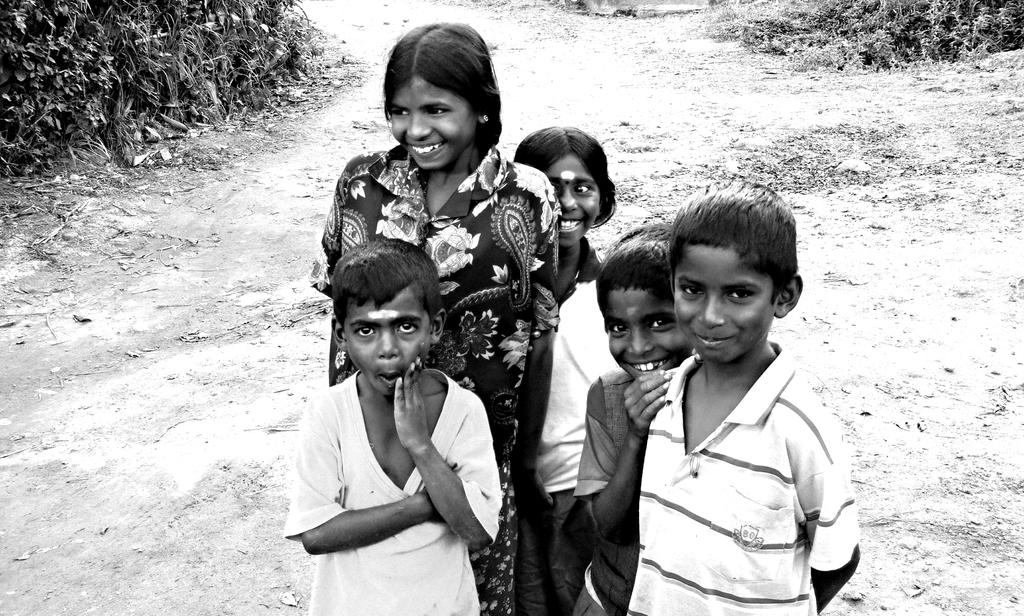What is the color scheme of the image? The image is black and white. How many people are in the image? There are a few people in the image. What can be seen on the ground in the image? The ground is visible in the image. What type of vegetation is present in the image? There is grass and plants in the image. What type of sand can be seen in the image? There is no sand present in the image; it features a black and white scene with people, grass, and plants. Is there a car visible in the image? There is no car present in the image. 